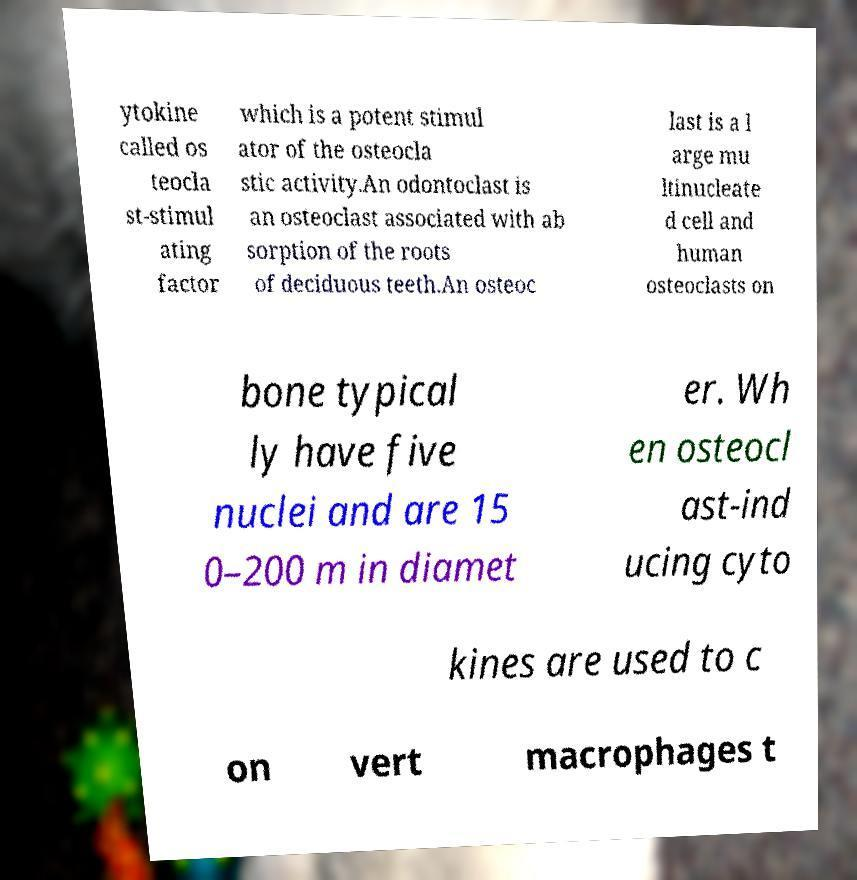Could you extract and type out the text from this image? ytokine called os teocla st-stimul ating factor which is a potent stimul ator of the osteocla stic activity.An odontoclast is an osteoclast associated with ab sorption of the roots of deciduous teeth.An osteoc last is a l arge mu ltinucleate d cell and human osteoclasts on bone typical ly have five nuclei and are 15 0–200 m in diamet er. Wh en osteocl ast-ind ucing cyto kines are used to c on vert macrophages t 